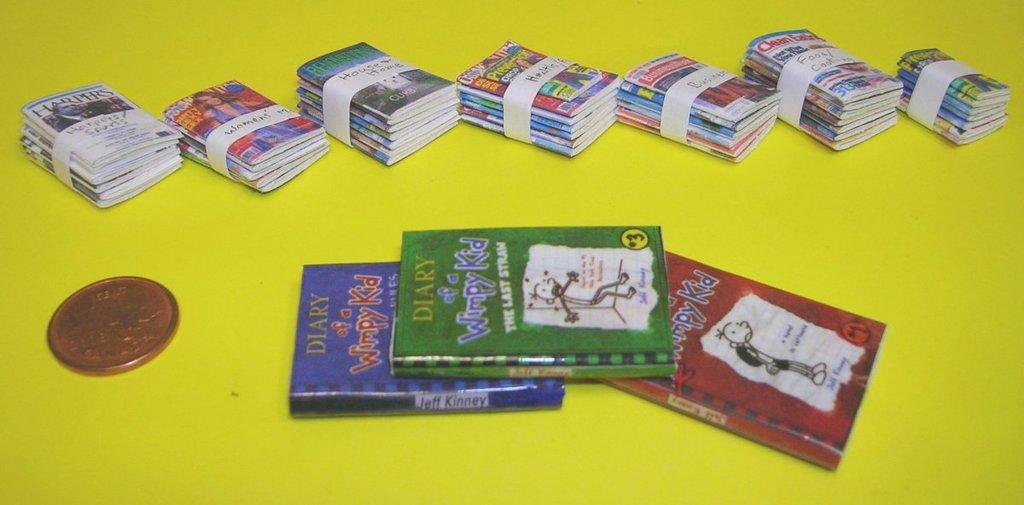<image>
Give a short and clear explanation of the subsequent image. Diary of a wimpy kid book collection and women magazines stacked together. 